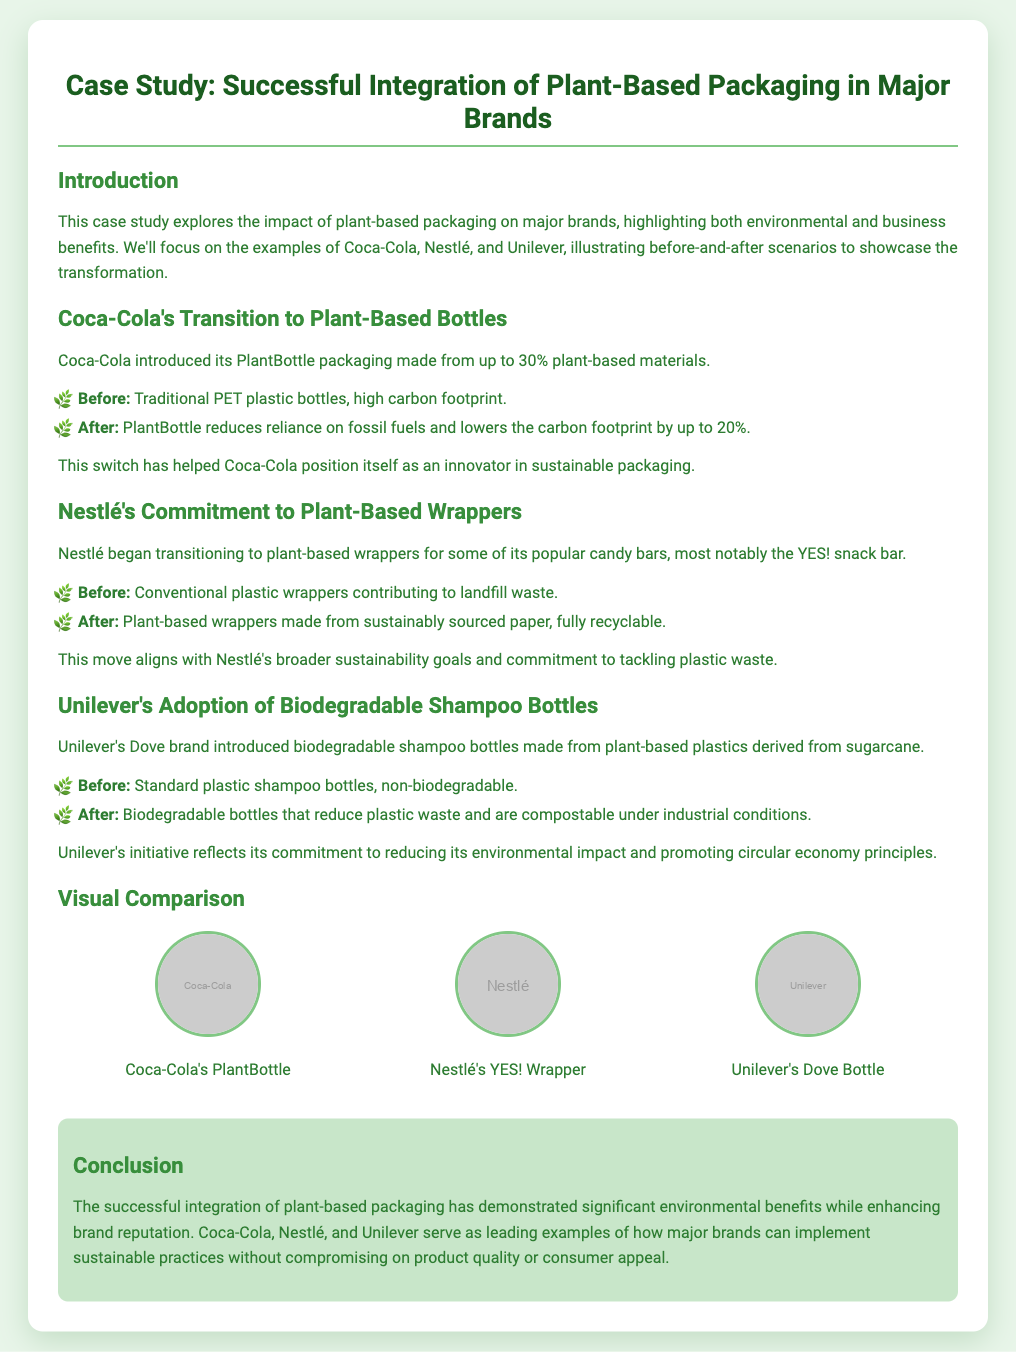What percentage of plant-based materials does Coca-Cola's PlantBottle contain? Coca-Cola's PlantBottle packaging is made from up to 30% plant-based materials, as stated in the document.
Answer: 30% What is the carbon footprint reduction percentage for Coca-Cola's PlantBottle? The document indicates that the PlantBottle reduces the carbon footprint by up to 20%.
Answer: 20% What type of packaging did Nestlé transition to for its YES! snack bar? Nestlé transitioned to plant-based wrappers made from sustainably sourced paper, according to the case study.
Answer: Plant-based wrappers What are Unilever's shampoo bottles made from? Unilever's Dove shampoo bottles are made from plant-based plastics derived from sugarcane, as mentioned in the document.
Answer: Plant-based plastics Which major brand introduced biodegradable shampoo bottles? The case study highlights that Unilever's Dove brand introduced biodegradable shampoo bottles.
Answer: Unilever How do the plant-based wrappers align with Nestlé's goals? The plant-based wrappers align with Nestlé's broader sustainability goals and commitment to tackling plastic waste, as described in the presentation.
Answer: Sustainability goals What visual format is used to compare packaging solutions? The visual format used to compare packaging solutions is a combination of images and descriptions of before-and-after scenarios.
Answer: Images and descriptions What is the main environmental benefit highlighted in the conclusion? The conclusion emphasizes that the successful integration of plant-based packaging has demonstrated significant environmental benefits.
Answer: Environmental benefits Which companies are featured as examples in the case study? The companies featured as examples in the case study are Coca-Cola, Nestlé, and Unilever, as listed in the introduction.
Answer: Coca-Cola, Nestlé, Unilever 